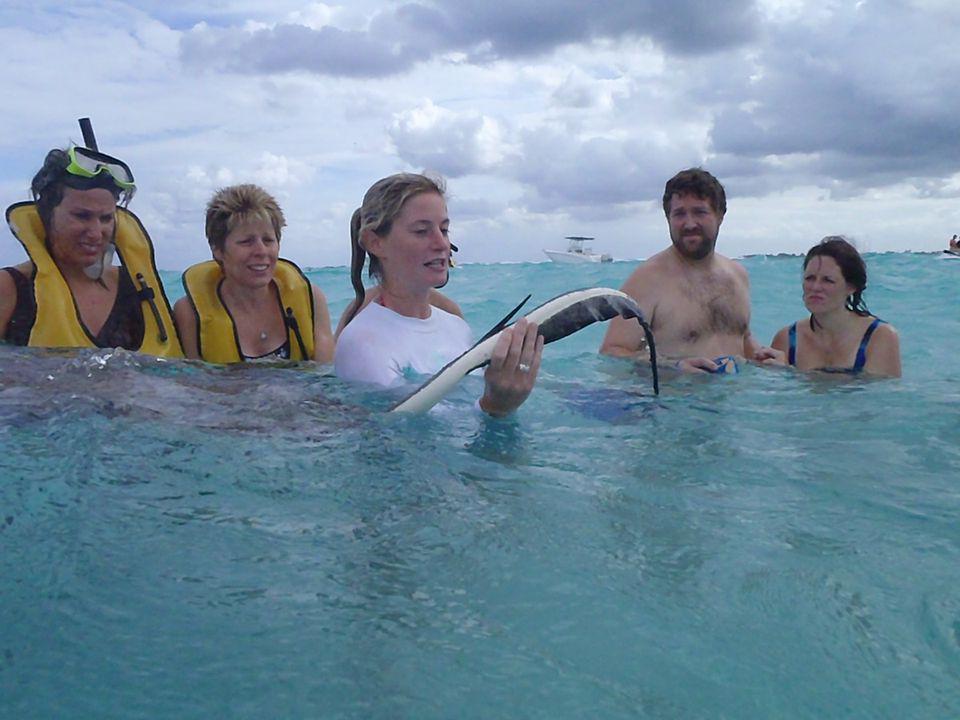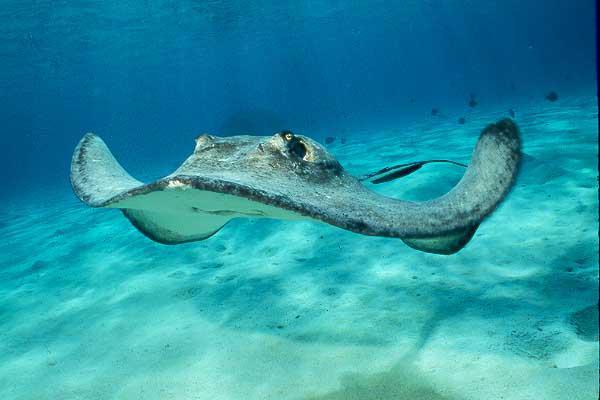The first image is the image on the left, the second image is the image on the right. For the images shown, is this caption "In one image, at least one person is in the water interacting with a stingray, and a snorkel is visible." true? Answer yes or no. Yes. The first image is the image on the left, the second image is the image on the right. Given the left and right images, does the statement "At least one human is in the ocean with the fish in one of the images." hold true? Answer yes or no. Yes. 